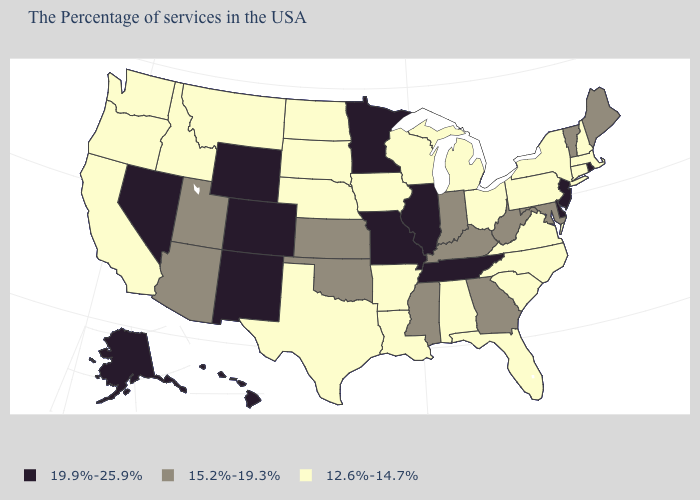Does the map have missing data?
Give a very brief answer. No. What is the value of Tennessee?
Be succinct. 19.9%-25.9%. What is the value of Ohio?
Concise answer only. 12.6%-14.7%. What is the value of New Jersey?
Answer briefly. 19.9%-25.9%. What is the value of Wisconsin?
Keep it brief. 12.6%-14.7%. Does Wisconsin have the lowest value in the MidWest?
Write a very short answer. Yes. What is the lowest value in the South?
Be succinct. 12.6%-14.7%. Name the states that have a value in the range 15.2%-19.3%?
Give a very brief answer. Maine, Vermont, Maryland, West Virginia, Georgia, Kentucky, Indiana, Mississippi, Kansas, Oklahoma, Utah, Arizona. Which states hav the highest value in the Northeast?
Answer briefly. Rhode Island, New Jersey. What is the value of Maryland?
Concise answer only. 15.2%-19.3%. What is the value of Idaho?
Short answer required. 12.6%-14.7%. Name the states that have a value in the range 12.6%-14.7%?
Keep it brief. Massachusetts, New Hampshire, Connecticut, New York, Pennsylvania, Virginia, North Carolina, South Carolina, Ohio, Florida, Michigan, Alabama, Wisconsin, Louisiana, Arkansas, Iowa, Nebraska, Texas, South Dakota, North Dakota, Montana, Idaho, California, Washington, Oregon. Does Nevada have a lower value than Rhode Island?
Concise answer only. No. Among the states that border West Virginia , does Maryland have the highest value?
Give a very brief answer. Yes. Name the states that have a value in the range 12.6%-14.7%?
Answer briefly. Massachusetts, New Hampshire, Connecticut, New York, Pennsylvania, Virginia, North Carolina, South Carolina, Ohio, Florida, Michigan, Alabama, Wisconsin, Louisiana, Arkansas, Iowa, Nebraska, Texas, South Dakota, North Dakota, Montana, Idaho, California, Washington, Oregon. 